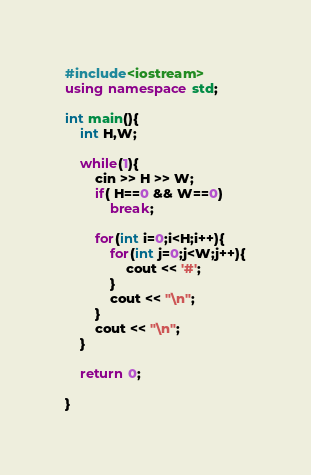<code> <loc_0><loc_0><loc_500><loc_500><_C++_>#include<iostream>
using namespace std;

int main(){
	int H,W;

	while(1){
		cin >> H >> W;
		if( H==0 && W==0)
			break;
		
		for(int i=0;i<H;i++){
			for(int j=0;j<W;j++){
				cout << '#';
			}
			cout << "\n";
		}
		cout << "\n";
	}

	return 0;
	
}</code> 